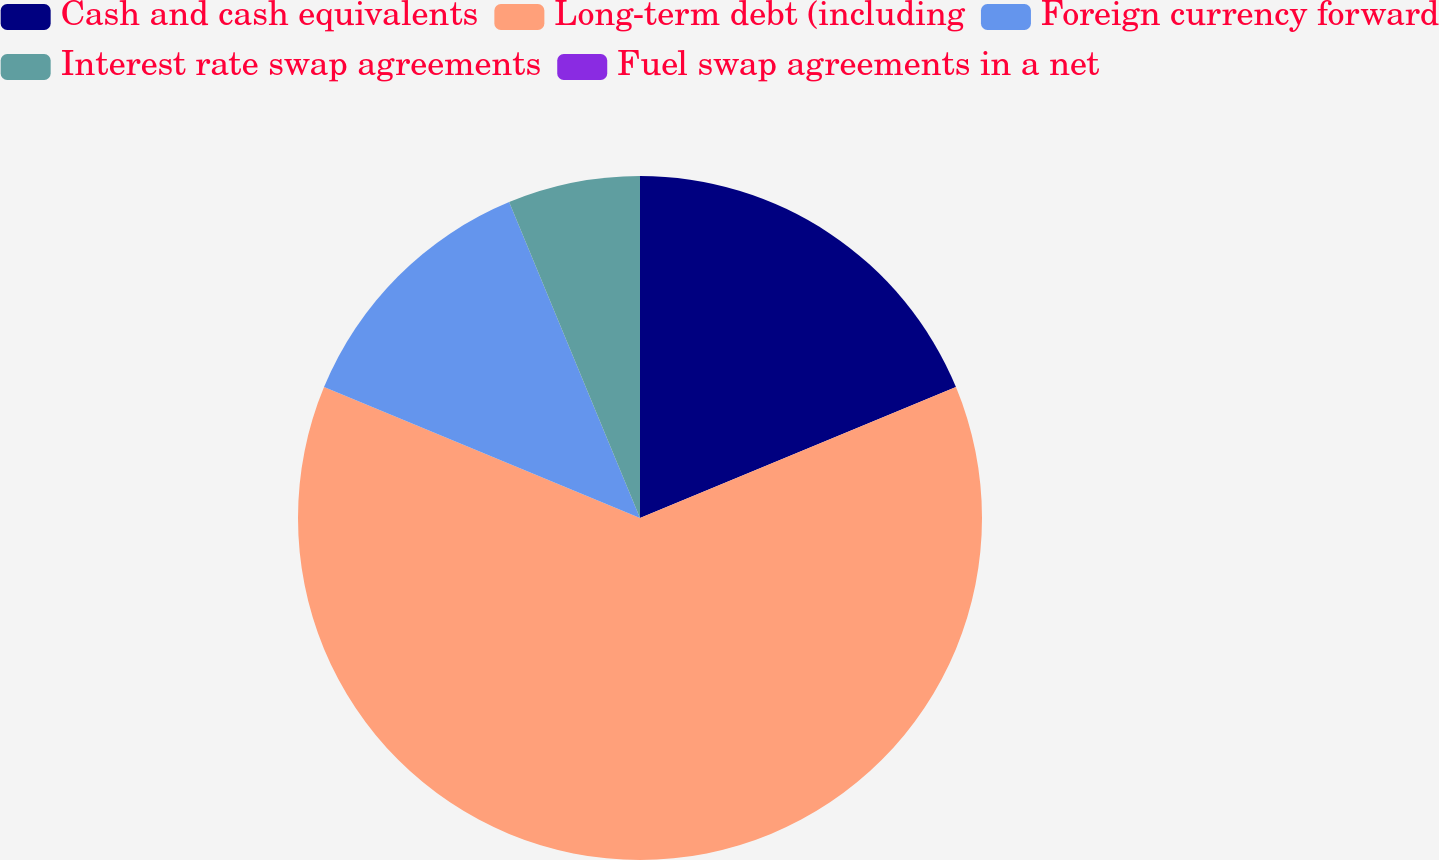Convert chart. <chart><loc_0><loc_0><loc_500><loc_500><pie_chart><fcel>Cash and cash equivalents<fcel>Long-term debt (including<fcel>Foreign currency forward<fcel>Interest rate swap agreements<fcel>Fuel swap agreements in a net<nl><fcel>18.75%<fcel>62.5%<fcel>12.5%<fcel>6.25%<fcel>0.0%<nl></chart> 